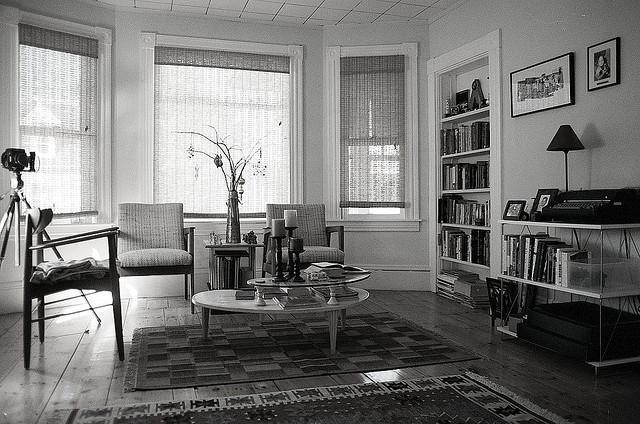How many windows are there?
Give a very brief answer. 3. How many lamps are there?
Give a very brief answer. 1. How many potted plants do you see?
Give a very brief answer. 0. How many chairs are visible?
Give a very brief answer. 3. How many people are in this picture?
Give a very brief answer. 0. 